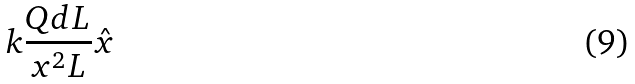Convert formula to latex. <formula><loc_0><loc_0><loc_500><loc_500>k \frac { Q d L } { x ^ { 2 } L } \hat { x }</formula> 